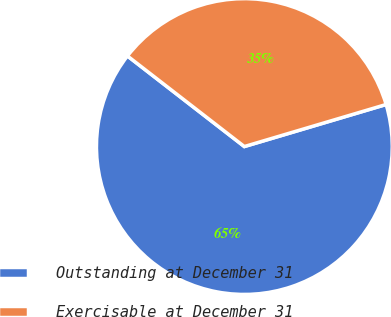<chart> <loc_0><loc_0><loc_500><loc_500><pie_chart><fcel>Outstanding at December 31<fcel>Exercisable at December 31<nl><fcel>65.08%<fcel>34.92%<nl></chart> 